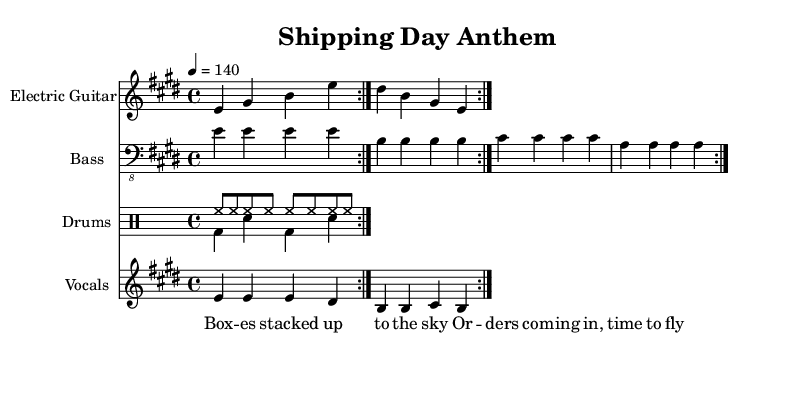What is the key signature of this music? The key signature is E major, which includes four sharps: F sharp, C sharp, G sharp, and D sharp.
Answer: E major What is the time signature of this piece? The time signature is 4/4, which means there are four beats per measure and the quarter note receives one beat.
Answer: 4/4 What is the tempo marking indicated in the music? The tempo marking is 140 beats per minute, indicating a fast and energetic pace for performance.
Answer: 140 How many times is the electric guitar section repeated in the score? The electric guitar part has a repeat notation indicating it is played twice in succession.
Answer: 2 What is the lyric content of the verse? The lyrics state "Boxes stacked up to the sky, Orders coming in, time to fly," reflecting a busy shipping theme.
Answer: Boxes stacked up to the sky How many pieces of percussion are highlighted in the score? There are two parts for drums: one for the hi-hat and one for the bass and snare, indicating a layered approach to percussion.
Answer: 2 What kind of song structure can be identified in this piece? The structure is typical for rock anthems, featuring repeated sections and a strong rhythmic foundation to maintain energy, specifically verses and instrumental breaks.
Answer: Repeated sections 